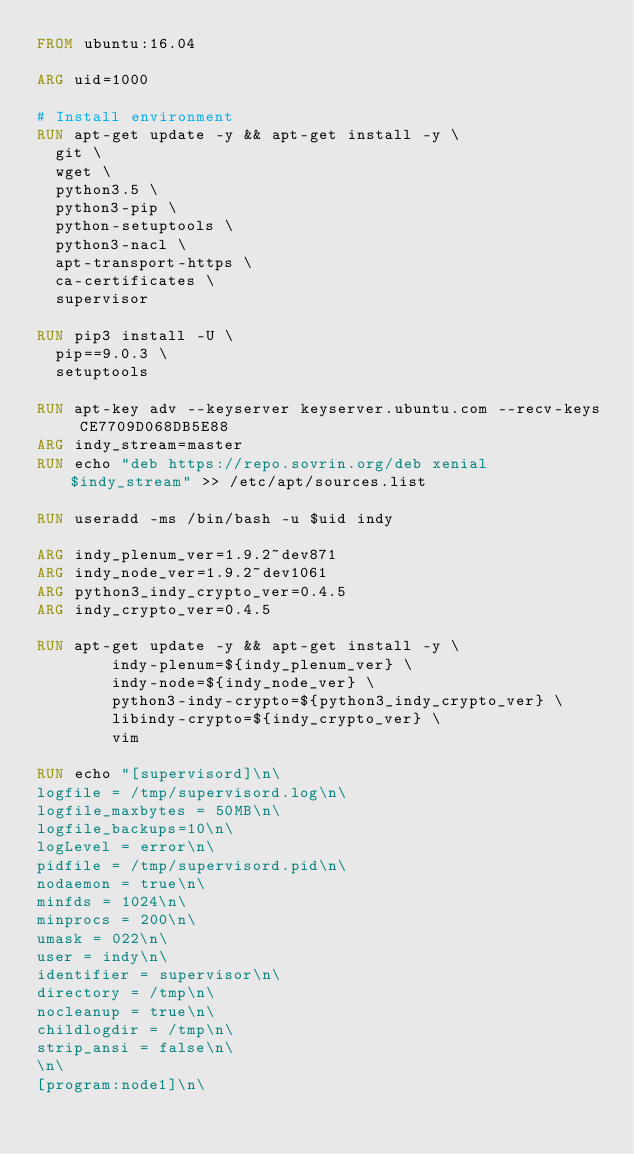Convert code to text. <code><loc_0><loc_0><loc_500><loc_500><_Dockerfile_>FROM ubuntu:16.04

ARG uid=1000

# Install environment
RUN apt-get update -y && apt-get install -y \
	git \
	wget \
	python3.5 \
	python3-pip \
	python-setuptools \
	python3-nacl \
	apt-transport-https \
	ca-certificates \
	supervisor

RUN pip3 install -U \
	pip==9.0.3 \
	setuptools

RUN apt-key adv --keyserver keyserver.ubuntu.com --recv-keys CE7709D068DB5E88
ARG indy_stream=master
RUN echo "deb https://repo.sovrin.org/deb xenial $indy_stream" >> /etc/apt/sources.list

RUN useradd -ms /bin/bash -u $uid indy

ARG indy_plenum_ver=1.9.2~dev871
ARG indy_node_ver=1.9.2~dev1061
ARG python3_indy_crypto_ver=0.4.5
ARG indy_crypto_ver=0.4.5

RUN apt-get update -y && apt-get install -y \
        indy-plenum=${indy_plenum_ver} \
        indy-node=${indy_node_ver} \
        python3-indy-crypto=${python3_indy_crypto_ver} \
        libindy-crypto=${indy_crypto_ver} \
        vim

RUN echo "[supervisord]\n\
logfile = /tmp/supervisord.log\n\
logfile_maxbytes = 50MB\n\
logfile_backups=10\n\
logLevel = error\n\
pidfile = /tmp/supervisord.pid\n\
nodaemon = true\n\
minfds = 1024\n\
minprocs = 200\n\
umask = 022\n\
user = indy\n\
identifier = supervisor\n\
directory = /tmp\n\
nocleanup = true\n\
childlogdir = /tmp\n\
strip_ansi = false\n\
\n\
[program:node1]\n\</code> 